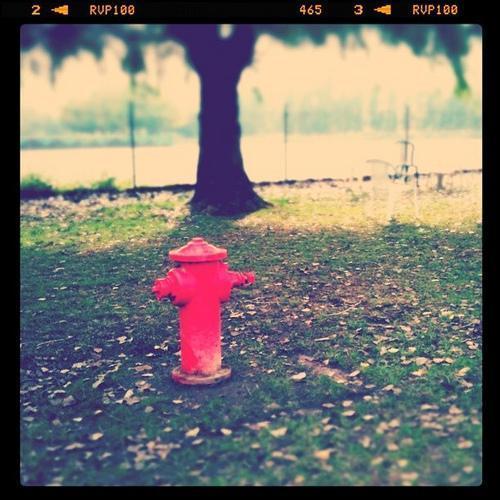How many hydrants are there?
Give a very brief answer. 1. 